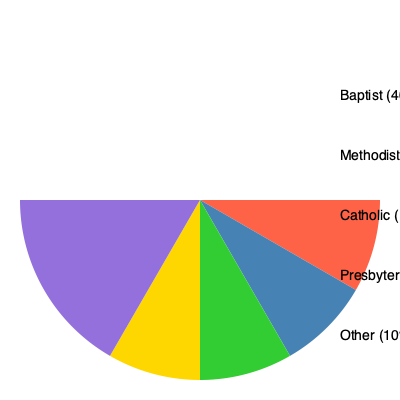Examining the pie chart of religious denominations in a community, how might a Baptist minister interpret the distribution in light of Acts 1:8, which speaks of being witnesses "in Jerusalem, and in all Judea and Samaria, and to the ends of the earth"? To answer this question, we need to consider the following steps:

1. Understand the biblical context:
   Acts 1:8 outlines a strategy for spreading the Gospel, starting locally and expanding outward.

2. Analyze the pie chart data:
   - Baptist: 40%
   - Methodist: 25%
   - Catholic: 15%
   - Presbyterian: 10%
   - Other: 10%

3. Interpret the data through a Baptist minister's perspective:
   a. "Jerusalem" (local focus): The 40% Baptist representation could be seen as the "Jerusalem" - the immediate local community.
   
   b. "Judea and Samaria" (nearby regions): The other Protestant denominations (Methodist 25%, Presbyterian 10%) might represent "Judea" - closely related but slightly different groups.
   
   c. "Ends of the earth" (far-reaching mission): The Catholic (15%) and Other (10%) categories could symbolize "Samaria and the ends of the earth" - groups that are more doctrinally distant or unknown.

4. Apply the biblical principle:
   The minister might interpret this distribution as a call to:
   - Strengthen and nurture the existing Baptist community (40%)
   - Engage in dialogue and potential unity with other Protestant denominations (35%)
   - Reach out to and understand the Catholic and Other groups (25%)

5. Legal doctrine parallel:
   Just as legal doctrines often start with precedent (akin to the local "Jerusalem") and then expand to wider interpretations and applications, the minister might see this religious distribution as a template for spiritual and community outreach.
Answer: The minister might interpret the chart as a divine map for local nurturing (40% Baptist), interfaith dialogue (35% other Protestants), and outreach (25% Catholic/Other), mirroring Acts 1:8's strategy of expanding witness from local to global. 